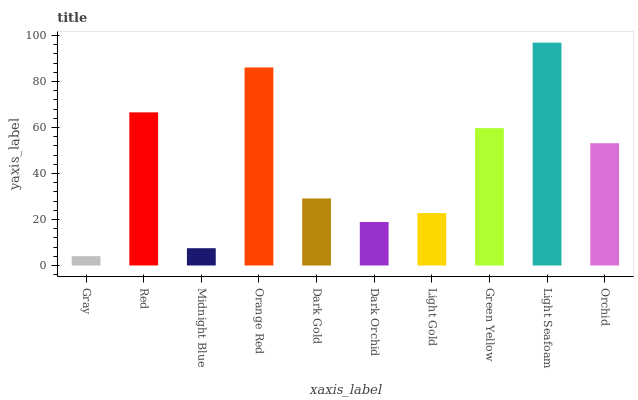Is Gray the minimum?
Answer yes or no. Yes. Is Light Seafoam the maximum?
Answer yes or no. Yes. Is Red the minimum?
Answer yes or no. No. Is Red the maximum?
Answer yes or no. No. Is Red greater than Gray?
Answer yes or no. Yes. Is Gray less than Red?
Answer yes or no. Yes. Is Gray greater than Red?
Answer yes or no. No. Is Red less than Gray?
Answer yes or no. No. Is Orchid the high median?
Answer yes or no. Yes. Is Dark Gold the low median?
Answer yes or no. Yes. Is Dark Orchid the high median?
Answer yes or no. No. Is Midnight Blue the low median?
Answer yes or no. No. 